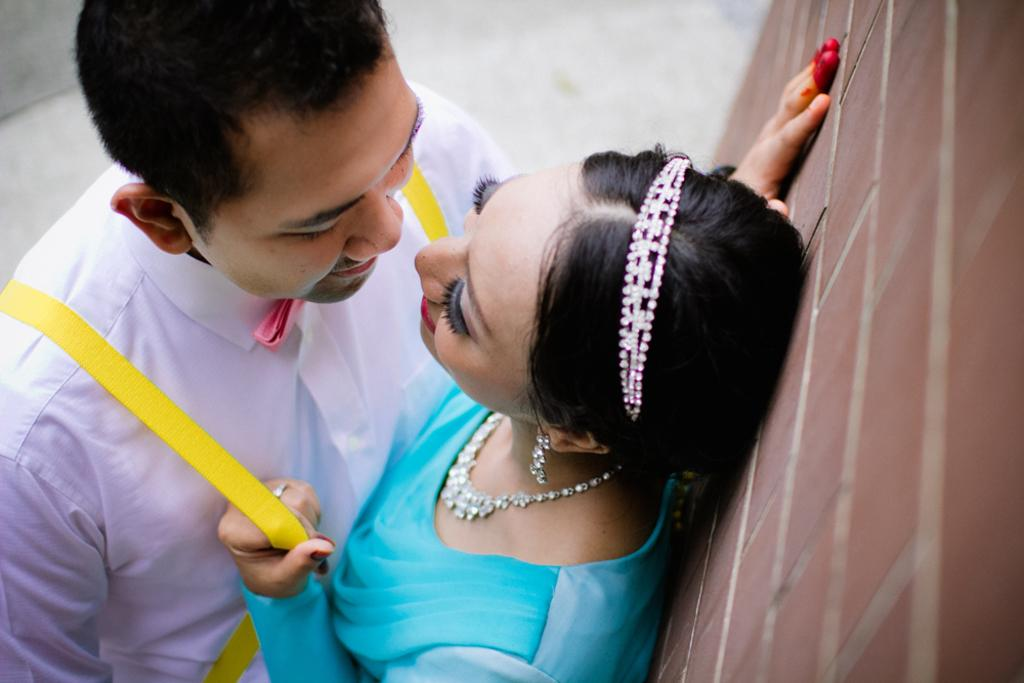How many people are in the image? There are two people in the image, a man and a woman. What are the man and woman doing in the image? The man and woman are standing. Where is the woman positioned in relation to the wall? The woman is standing in front of a wall. What expressions do the man and woman have in the image? The man and woman are smiling. What type of canvas is visible in the image? There is no canvas present in the image. What things can be seen on the wall behind the woman? The provided facts do not mention any specific things on the wall behind the woman. 